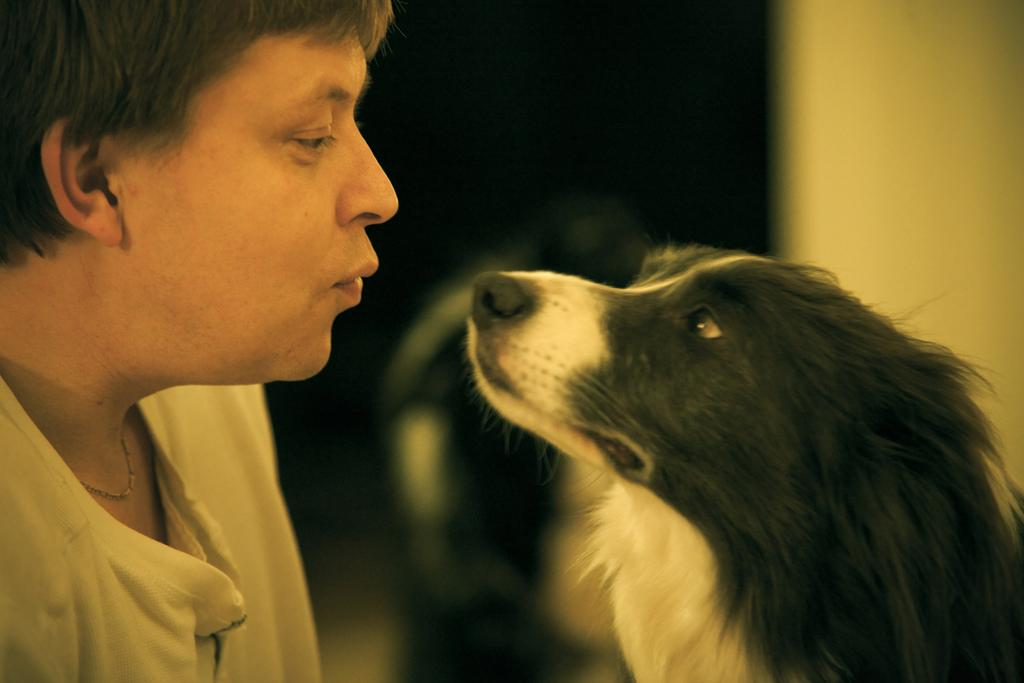What is present in the image along with the person? There is a dog in the image. What object can be seen on the right side of the image? There is a pole on the right side of the image. What type of disgust can be seen on the lawyer's face in the image? There is no lawyer present in the image, and therefore no facial expressions to analyze. What type of stem is growing from the dog's back in the image? There is no stem growing from the dog's back in the image. 